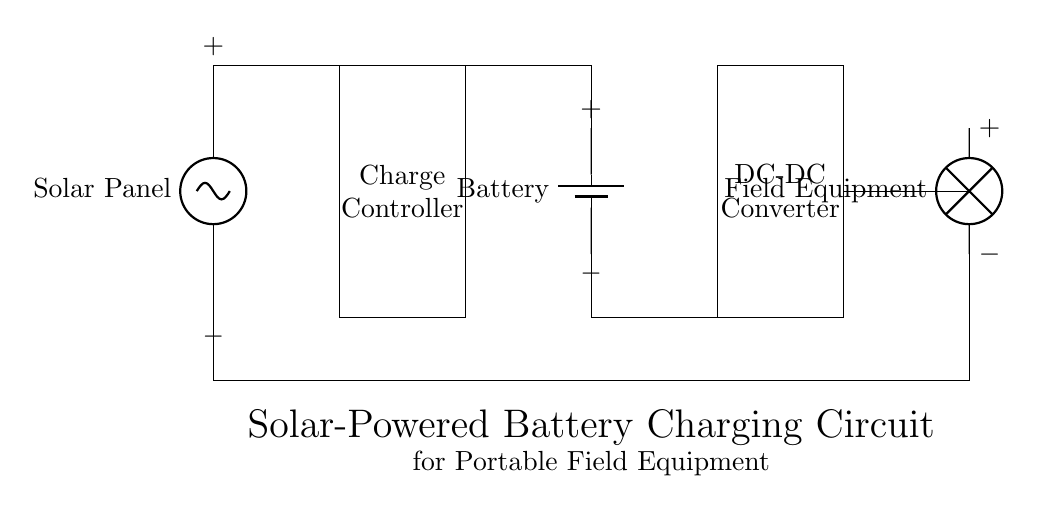What component converts solar energy to electrical energy? The solar panel is the component that captures sunlight and converts it into electrical energy.
Answer: Solar Panel What is located after the solar panel in the circuit? The charge controller is directly connected after the solar panel, which regulates the voltage and current going to the battery.
Answer: Charge Controller What role does the battery play in this circuit? The battery stores the electrical energy generated by the solar panel for later use by the field equipment.
Answer: Energy Storage How many main components are in this circuit? The circuit includes five main components: solar panel, charge controller, battery, DC-DC converter, and field equipment.
Answer: Five What is the purpose of the DC-DC converter in this circuit? The DC-DC converter adjusts the voltage from the battery to provide the appropriate voltage that the field equipment requires.
Answer: Voltage Adjustment What is the voltage polarity at the solar panel's output? The positive terminal is at the top and the negative terminal is at the bottom of the solar panel output.
Answer: Positive at Top What can be inferred about the flow of energy in this circuit? Energy flows from the solar panel to the charge controller, then to the battery, and finally to the field equipment through the DC-DC converter.
Answer: Linear Flow 